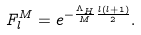Convert formula to latex. <formula><loc_0><loc_0><loc_500><loc_500>F _ { l } ^ { M } = e ^ { - \frac { \Lambda _ { H } } { M } \frac { l ( l + 1 ) } { 2 } } .</formula> 